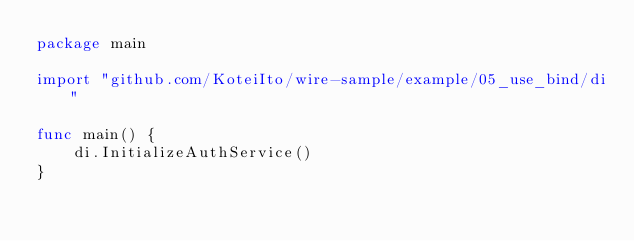<code> <loc_0><loc_0><loc_500><loc_500><_Go_>package main

import "github.com/KoteiIto/wire-sample/example/05_use_bind/di"

func main() {
	di.InitializeAuthService()
}
</code> 